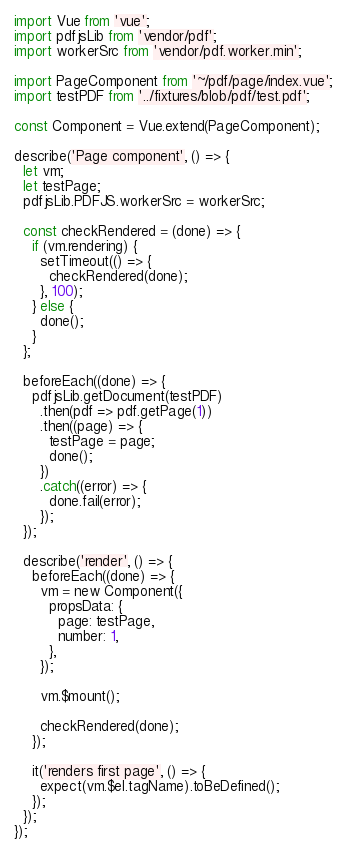Convert code to text. <code><loc_0><loc_0><loc_500><loc_500><_JavaScript_>import Vue from 'vue';
import pdfjsLib from 'vendor/pdf';
import workerSrc from 'vendor/pdf.worker.min';

import PageComponent from '~/pdf/page/index.vue';
import testPDF from '../fixtures/blob/pdf/test.pdf';

const Component = Vue.extend(PageComponent);

describe('Page component', () => {
  let vm;
  let testPage;
  pdfjsLib.PDFJS.workerSrc = workerSrc;

  const checkRendered = (done) => {
    if (vm.rendering) {
      setTimeout(() => {
        checkRendered(done);
      }, 100);
    } else {
      done();
    }
  };

  beforeEach((done) => {
    pdfjsLib.getDocument(testPDF)
      .then(pdf => pdf.getPage(1))
      .then((page) => {
        testPage = page;
        done();
      })
      .catch((error) => {
        done.fail(error);
      });
  });

  describe('render', () => {
    beforeEach((done) => {
      vm = new Component({
        propsData: {
          page: testPage,
          number: 1,
        },
      });

      vm.$mount();

      checkRendered(done);
    });

    it('renders first page', () => {
      expect(vm.$el.tagName).toBeDefined();
    });
  });
});
</code> 